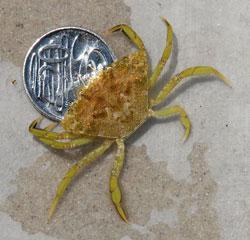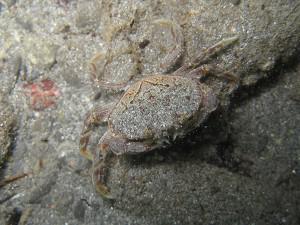The first image is the image on the left, the second image is the image on the right. Examine the images to the left and right. Is the description "The left image contains a human touching a crab." accurate? Answer yes or no. No. The first image is the image on the left, the second image is the image on the right. For the images shown, is this caption "In at least one image there is a hand touching a crab." true? Answer yes or no. No. 